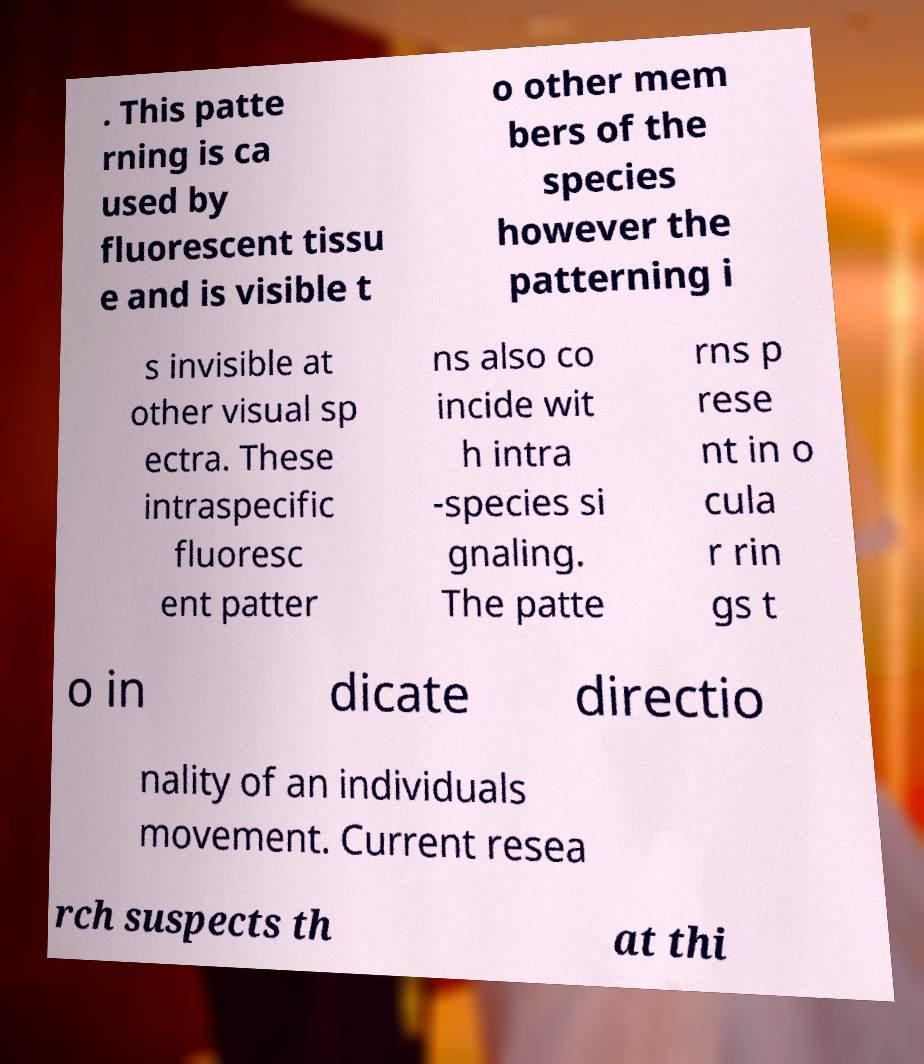For documentation purposes, I need the text within this image transcribed. Could you provide that? . This patte rning is ca used by fluorescent tissu e and is visible t o other mem bers of the species however the patterning i s invisible at other visual sp ectra. These intraspecific fluoresc ent patter ns also co incide wit h intra -species si gnaling. The patte rns p rese nt in o cula r rin gs t o in dicate directio nality of an individuals movement. Current resea rch suspects th at thi 